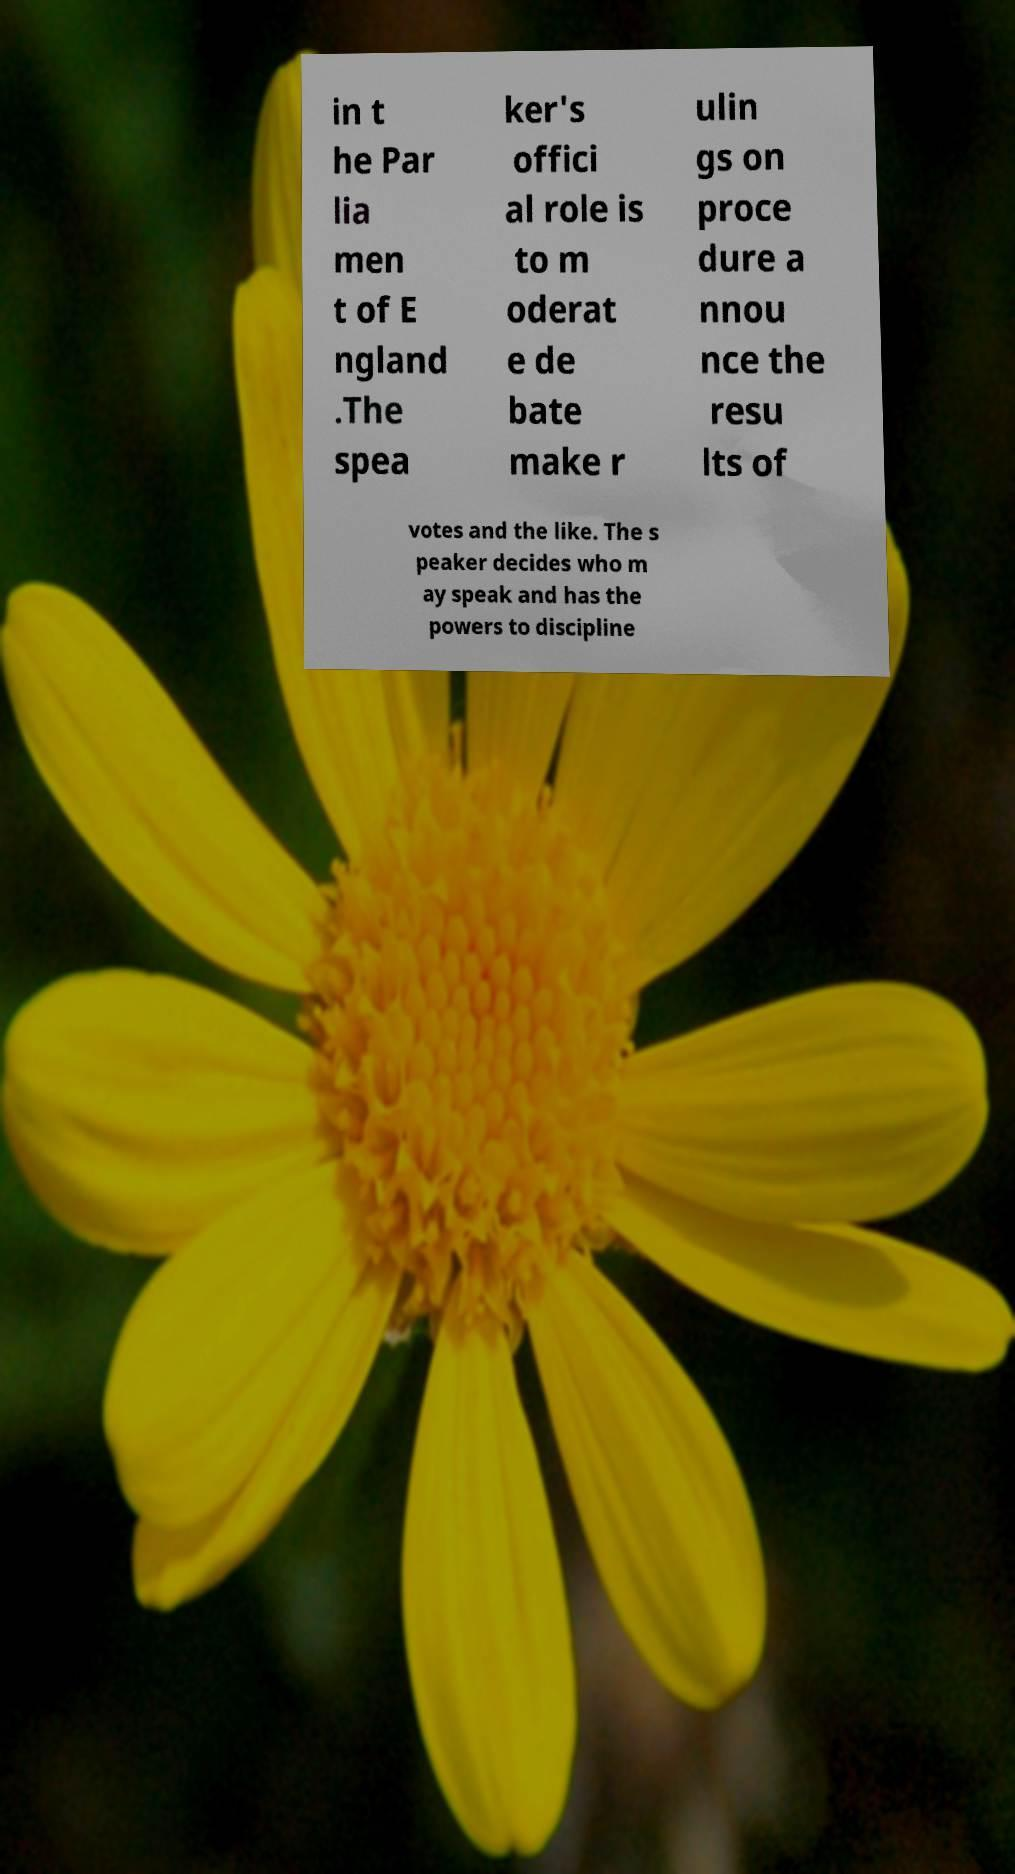What messages or text are displayed in this image? I need them in a readable, typed format. in t he Par lia men t of E ngland .The spea ker's offici al role is to m oderat e de bate make r ulin gs on proce dure a nnou nce the resu lts of votes and the like. The s peaker decides who m ay speak and has the powers to discipline 